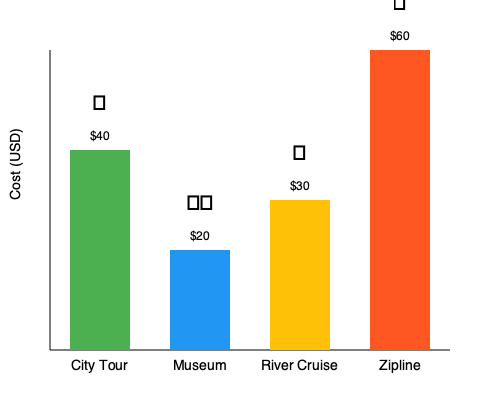As a budget traveler, which two activities would you recommend for the best value, considering both cost and experience variety? To answer this question, we need to analyze the cost and nature of each activity:

1. City Tour (🚌): $40
   - Offers a comprehensive view of the city
   - Mid-range price

2. Museum (🏛️): $20
   - Lowest cost option
   - Cultural and educational experience

3. River Cruise (🚢): $30
   - Scenic experience
   - Second lowest price

4. Zipline (🚡): $60
   - Highest cost option
   - Thrilling adventure experience

As a budget traveler, we want to maximize experience while minimizing cost. The two best value options are:

1. Museum ($20): Cheapest option, providing cultural enrichment
2. River Cruise ($30): Affordable, offering a unique perspective of the city

These two activities provide a good balance of indoor (museum) and outdoor (river cruise) experiences at the lowest combined cost of $50. They offer variety in terms of cultural and scenic experiences while staying within a budget-friendly range.

The City Tour, while comprehensive, is more expensive and might overlap with sights seen during the River Cruise. The Zipline, while exciting, is the most expensive and may not align with typical budget traveler priorities.
Answer: Museum and River Cruise 